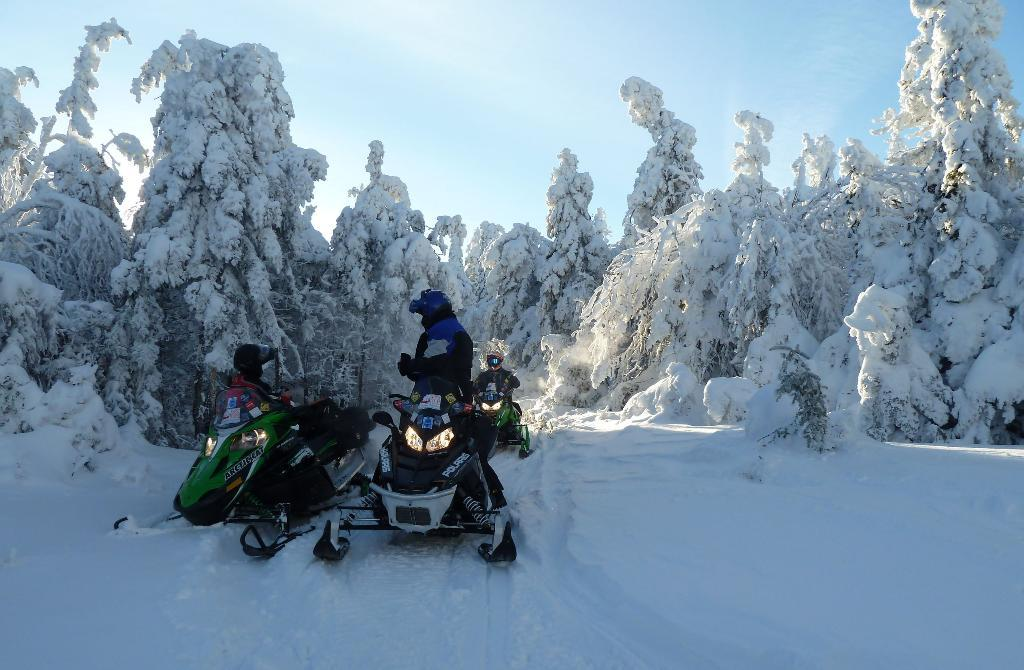What are the people in the image doing? The people in the image are riding snowmobiles. Where are the snowmobiles located? The snowmobiles are on the ice. What can be seen in the background of the image? There is a group of trees in the image, and they are covered with snow. What is the condition of the sky in the image? The sky looks cloudy in the image. How many friends are washing their toes in the image? There are no friends washing their toes in the image; the people are riding snowmobiles on the ice. 